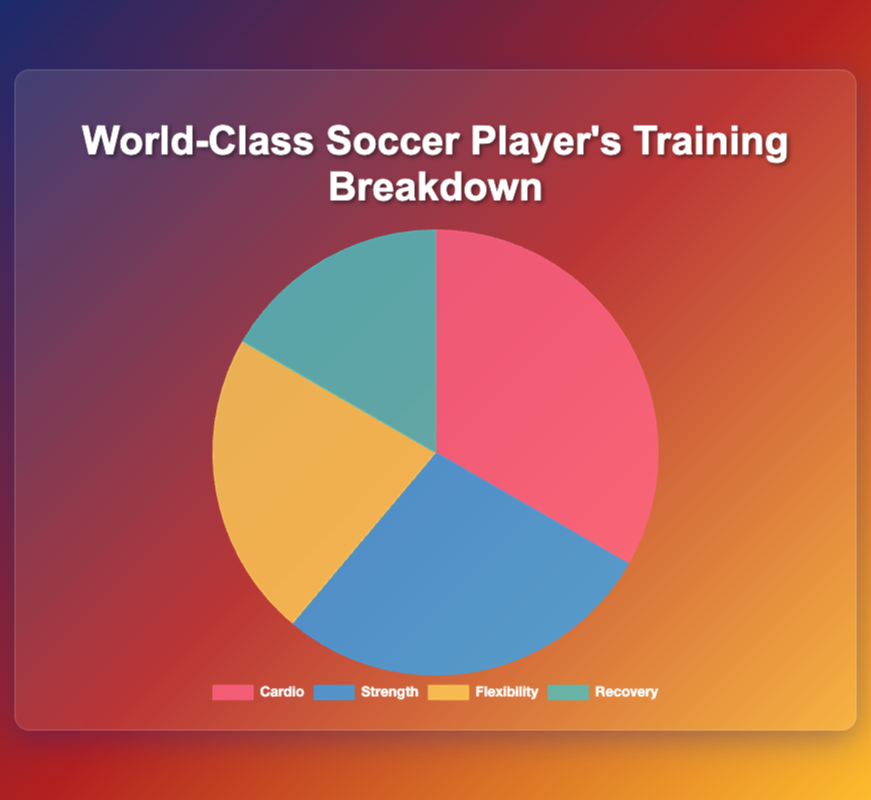What is the total duration spent on Strength and Flexibility exercises combined? The duration for Strength is 150 minutes and for Flexibility is 120 minutes. Add these two durations: 150 + 120 = 270.
Answer: 270 minutes Which type of exercise has the shortest duration, and what is the duration? Refer to the data values and identify the type of exercise with the smallest number. Recovery has the shortest duration of 90 minutes.
Answer: Recovery, 90 minutes How much more time is spent on Cardio compared to Recovery? The duration for Cardio is 180 minutes and for Recovery is 90 minutes. Subtract the Recovery duration from the Cardio duration: 180 - 90 = 90.
Answer: 90 minutes What percentage of the total training time is dedicated to Flexibility exercises? The total duration is the sum of all exercises: 180 (Cardio) + 150 (Strength) + 120 (Flexibility) + 90 (Recovery) = 540 minutes. The Flexibility duration is 120 minutes. Calculate the percentage: (120 / 540) * 100 ≈ 22.22%.
Answer: 22.22% Are there more sessions per week dedicated to Strength or Flexibility exercises? The data shows there are 3 sessions per week dedicated to Strength and 2 sessions per week dedicated to Flexibility. Comparing these, Strength has more sessions per week.
Answer: Strength What is the ratio of Cardio to Recovery session durations? The duration for Cardio is 180 minutes and for Recovery is 90 minutes. The ratio is 180:90 which simplifies to 2:1.
Answer: 2:1 Which type of exercise has the largest duration, and how much larger is it compared to the next largest? Identify the largest duration: Cardio with 180 minutes. The next largest is Strength with 150 minutes. Subtract the two: 180 - 150 = 30. Cardio is 30 minutes longer than Strength.
Answer: Cardio, 30 minutes How many total minutes are spent on the main activities of Cardio and Strength exercises combined? The duration for Cardio is 180 minutes, and the main activity is Running, which covers the entire duration. The duration for Strength is 150 minutes, and the main activity is Weightlifting, which covers the entire duration. Add these durations: 180 + 150 = 330 minutes.
Answer: 330 minutes 